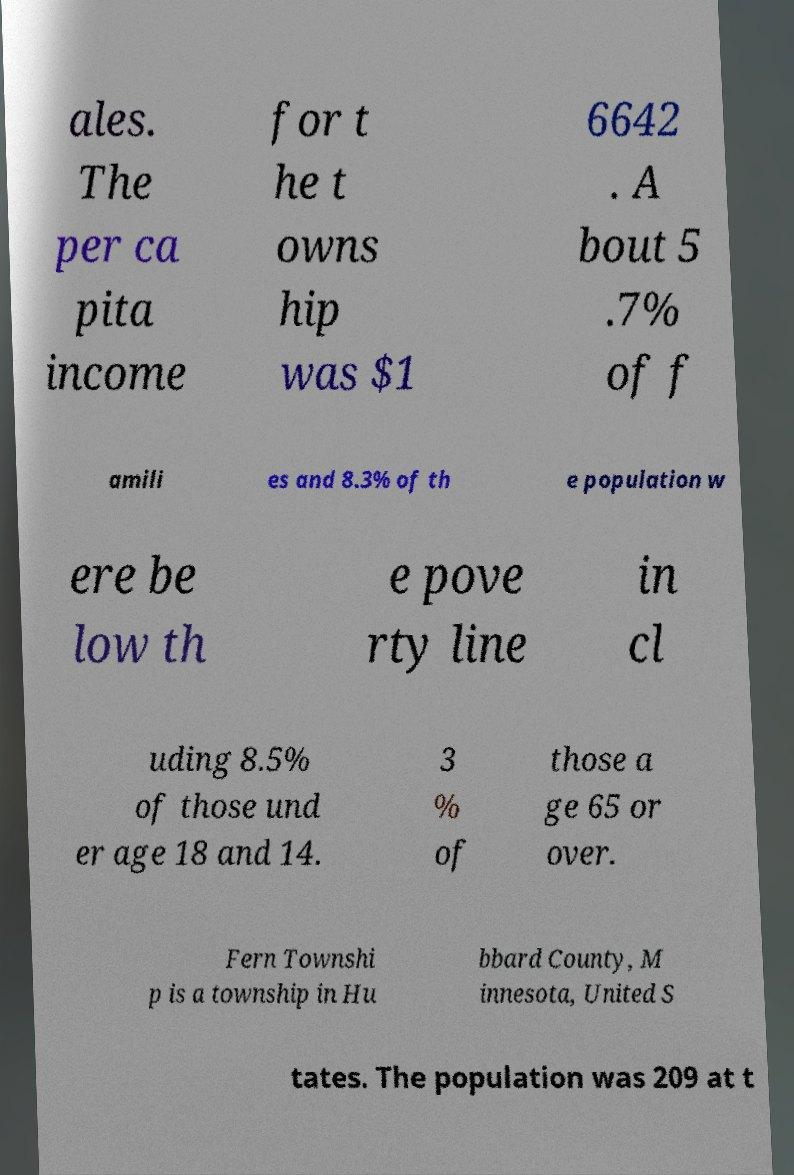For documentation purposes, I need the text within this image transcribed. Could you provide that? ales. The per ca pita income for t he t owns hip was $1 6642 . A bout 5 .7% of f amili es and 8.3% of th e population w ere be low th e pove rty line in cl uding 8.5% of those und er age 18 and 14. 3 % of those a ge 65 or over. Fern Townshi p is a township in Hu bbard County, M innesota, United S tates. The population was 209 at t 